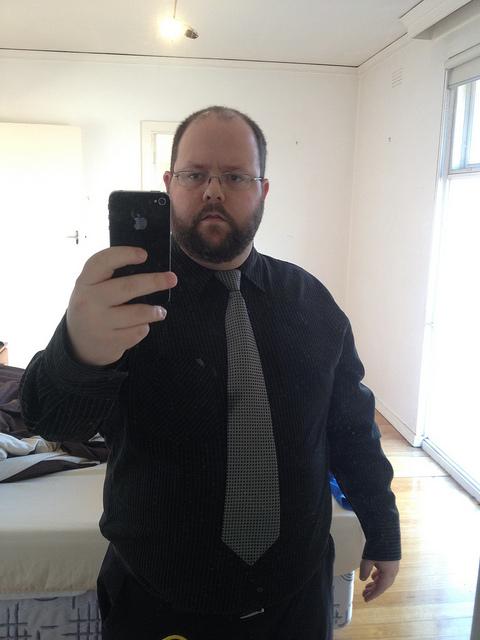What type of cuffs are on this man's shirt?
Quick response, please. Black. Is the man outside?
Quick response, please. No. Is the man wearing a winter coat?
Keep it brief. No. Is the man making a funny face?
Give a very brief answer. No. What is on the man's face?
Keep it brief. Beard. What is the man holding?
Concise answer only. Cell phone. 